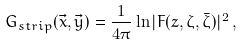<formula> <loc_0><loc_0><loc_500><loc_500>G _ { s t r i p } ( \vec { x } , \vec { y } ) = { \frac { 1 } { 4 \pi } } \ln | F ( z , \zeta , \bar { \zeta } ) | ^ { 2 } \, ,</formula> 